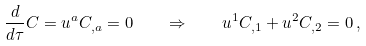Convert formula to latex. <formula><loc_0><loc_0><loc_500><loc_500>\frac { d } { d \tau } C = u ^ { a } C _ { , a } = 0 \quad \Rightarrow \quad u ^ { 1 } C _ { , 1 } + u ^ { 2 } C _ { , 2 } = 0 \, ,</formula> 